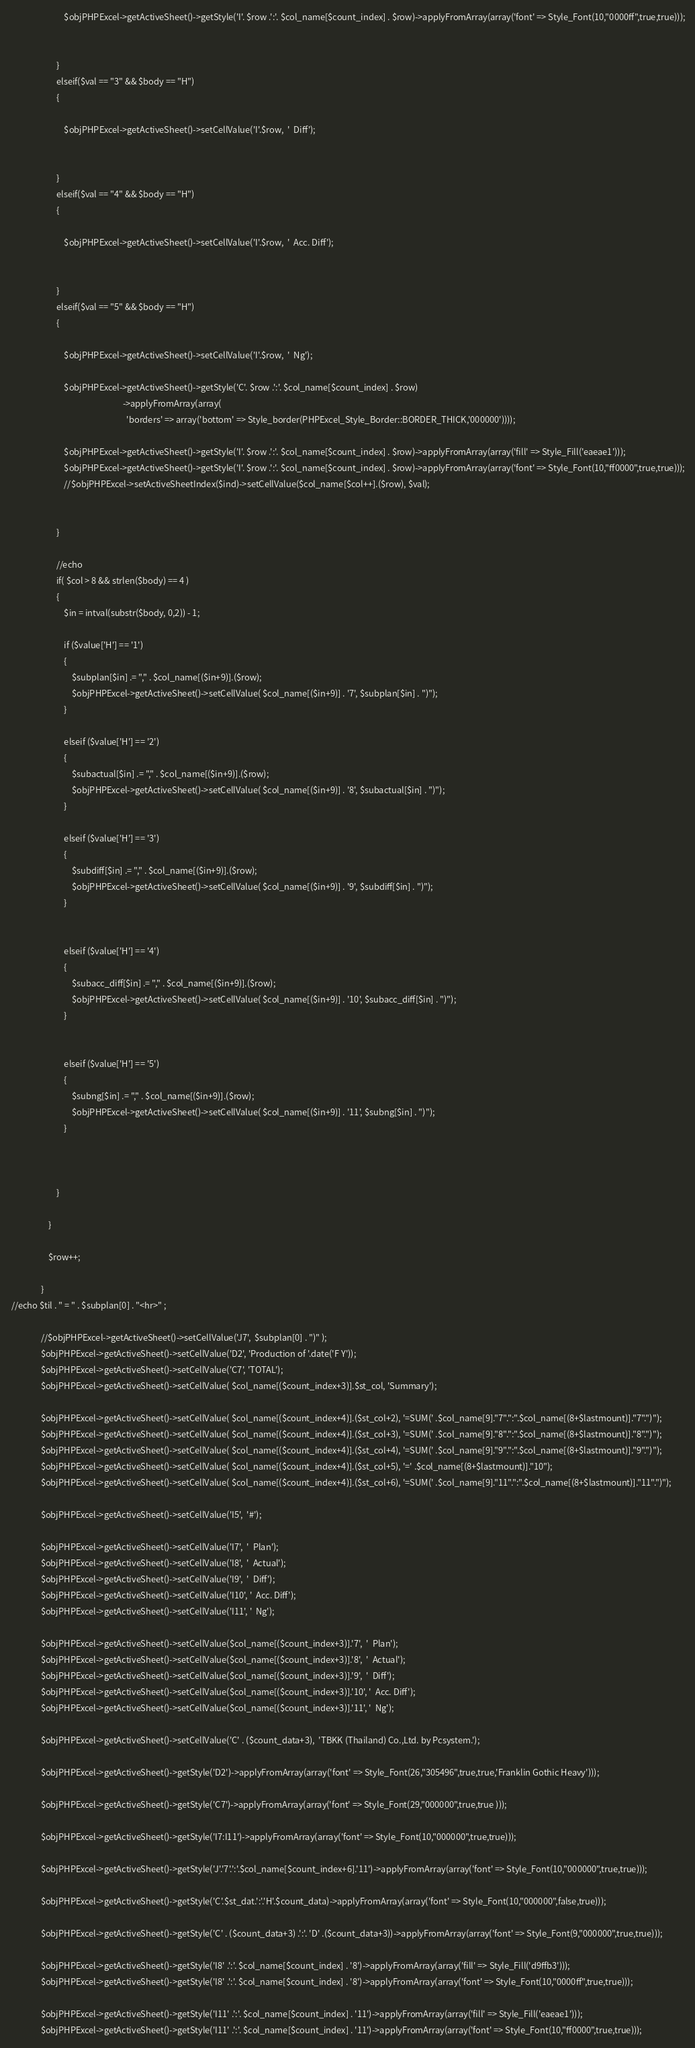<code> <loc_0><loc_0><loc_500><loc_500><_PHP_>                            $objPHPExcel->getActiveSheet()->getStyle('I'. $row .':'. $col_name[$count_index] . $row)->applyFromArray(array('font' => Style_Font(10,"0000ff",true,true)));


                        }  
                        elseif($val == "3" && $body == "H")
                        {

                            $objPHPExcel->getActiveSheet()->setCellValue('I'.$row,  '  Diff');


                        }
                        elseif($val == "4" && $body == "H")
                        {

                            $objPHPExcel->getActiveSheet()->setCellValue('I'.$row,  '  Acc. Diff');


                        }
                        elseif($val == "5" && $body == "H")
                        {

                            $objPHPExcel->getActiveSheet()->setCellValue('I'.$row,  '  Ng');

                            $objPHPExcel->getActiveSheet()->getStyle('C'. $row .':'. $col_name[$count_index] . $row)
                                                          ->applyFromArray(array(
                                                            'borders' => array('bottom' => Style_border(PHPExcel_Style_Border::BORDER_THICK,'000000'))));

                            $objPHPExcel->getActiveSheet()->getStyle('I'. $row .':'. $col_name[$count_index] . $row)->applyFromArray(array('fill' => Style_Fill('eaeae1')));
                            $objPHPExcel->getActiveSheet()->getStyle('I'. $row .':'. $col_name[$count_index] . $row)->applyFromArray(array('font' => Style_Font(10,"ff0000",true,true)));
                            //$objPHPExcel->setActiveSheetIndex($ind)->setCellValue($col_name[$col++].($row), $val);

                            
                        }  

                        //echo 
                        if( $col > 8 && strlen($body) == 4 )
                        {
                            $in = intval(substr($body, 0,2)) - 1;

                            if ($value['H'] == '1')
                            {
                                $subplan[$in] .= "," . $col_name[($in+9)].($row);
                                $objPHPExcel->getActiveSheet()->setCellValue( $col_name[($in+9)] . '7', $subplan[$in] . ")");
                            }

                            elseif ($value['H'] == '2')
                            {
                                $subactual[$in] .= "," . $col_name[($in+9)].($row);
                                $objPHPExcel->getActiveSheet()->setCellValue( $col_name[($in+9)] . '8', $subactual[$in] . ")");
                            }

                            elseif ($value['H'] == '3')
                            {
                                $subdiff[$in] .= "," . $col_name[($in+9)].($row);
                                $objPHPExcel->getActiveSheet()->setCellValue( $col_name[($in+9)] . '9', $subdiff[$in] . ")");
                            }


                            elseif ($value['H'] == '4')
                            {
                                $subacc_diff[$in] .= "," . $col_name[($in+9)].($row);
                                $objPHPExcel->getActiveSheet()->setCellValue( $col_name[($in+9)] . '10', $subacc_diff[$in] . ")");
                            }


                            elseif ($value['H'] == '5')
                            {
                                $subng[$in] .= "," . $col_name[($in+9)].($row);
                                $objPHPExcel->getActiveSheet()->setCellValue( $col_name[($in+9)] . '11', $subng[$in] . ")");
                            }                                                                                    



                        }

                    }

                    $row++;         

                }
 //echo $til . " = " . $subplan[0] . "<hr>" ;

                //$objPHPExcel->getActiveSheet()->setCellValue('J7',  $subplan[0] . ")" );
                $objPHPExcel->getActiveSheet()->setCellValue('D2', 'Production of '.date('F Y'));
                $objPHPExcel->getActiveSheet()->setCellValue('C7', 'TOTAL');
                $objPHPExcel->getActiveSheet()->setCellValue( $col_name[($count_index+3)].$st_col, 'Summary');

                $objPHPExcel->getActiveSheet()->setCellValue( $col_name[($count_index+4)].($st_col+2), '=SUM(' .$col_name[9]."7".":".$col_name[(8+$lastmount)]."7".")");
                $objPHPExcel->getActiveSheet()->setCellValue( $col_name[($count_index+4)].($st_col+3), '=SUM(' .$col_name[9]."8".":".$col_name[(8+$lastmount)]."8".")");
                $objPHPExcel->getActiveSheet()->setCellValue( $col_name[($count_index+4)].($st_col+4), '=SUM(' .$col_name[9]."9".":".$col_name[(8+$lastmount)]."9".")");
                $objPHPExcel->getActiveSheet()->setCellValue( $col_name[($count_index+4)].($st_col+5), '=' .$col_name[(8+$lastmount)]."10");
                $objPHPExcel->getActiveSheet()->setCellValue( $col_name[($count_index+4)].($st_col+6), '=SUM(' .$col_name[9]."11".":".$col_name[(8+$lastmount)]."11".")");

                $objPHPExcel->getActiveSheet()->setCellValue('I5',  '#');

                $objPHPExcel->getActiveSheet()->setCellValue('I7',  '  Plan');
                $objPHPExcel->getActiveSheet()->setCellValue('I8',  '  Actual');
                $objPHPExcel->getActiveSheet()->setCellValue('I9',  '  Diff');
                $objPHPExcel->getActiveSheet()->setCellValue('I10', '  Acc. Diff');
                $objPHPExcel->getActiveSheet()->setCellValue('I11', '  Ng');

                $objPHPExcel->getActiveSheet()->setCellValue($col_name[($count_index+3)].'7',  '  Plan');
                $objPHPExcel->getActiveSheet()->setCellValue($col_name[($count_index+3)].'8',  '  Actual');
                $objPHPExcel->getActiveSheet()->setCellValue($col_name[($count_index+3)].'9',  '  Diff');
                $objPHPExcel->getActiveSheet()->setCellValue($col_name[($count_index+3)].'10', '  Acc. Diff');
                $objPHPExcel->getActiveSheet()->setCellValue($col_name[($count_index+3)].'11', '  Ng');

                $objPHPExcel->getActiveSheet()->setCellValue('C' . ($count_data+3),  'TBKK (Thailand) Co.,Ltd. by Pcsystem.');

                $objPHPExcel->getActiveSheet()->getStyle('D2')->applyFromArray(array('font' => Style_Font(26,"305496",true,true,'Franklin Gothic Heavy')));

                $objPHPExcel->getActiveSheet()->getStyle('C7')->applyFromArray(array('font' => Style_Font(29,"000000",true,true )));

                $objPHPExcel->getActiveSheet()->getStyle('I7:I11')->applyFromArray(array('font' => Style_Font(10,"000000",true,true)));

                $objPHPExcel->getActiveSheet()->getStyle('J'.'7'.':'.$col_name[$count_index+6].'11')->applyFromArray(array('font' => Style_Font(10,"000000",true,true)));              

                $objPHPExcel->getActiveSheet()->getStyle('C'.$st_dat.':'.'H'.$count_data)->applyFromArray(array('font' => Style_Font(10,"000000",false,true)));

                $objPHPExcel->getActiveSheet()->getStyle('C' . ($count_data+3) .':'. 'D' .($count_data+3))->applyFromArray(array('font' => Style_Font(9,"000000",true,true)));

                $objPHPExcel->getActiveSheet()->getStyle('I8' .':'. $col_name[$count_index] . '8')->applyFromArray(array('fill' => Style_Fill('d9ffb3')));
                $objPHPExcel->getActiveSheet()->getStyle('I8' .':'. $col_name[$count_index] . '8')->applyFromArray(array('font' => Style_Font(10,"0000ff",true,true)));

                $objPHPExcel->getActiveSheet()->getStyle('I11' .':'. $col_name[$count_index] . '11')->applyFromArray(array('fill' => Style_Fill('eaeae1')));
                $objPHPExcel->getActiveSheet()->getStyle('I11' .':'. $col_name[$count_index] . '11')->applyFromArray(array('font' => Style_Font(10,"ff0000",true,true)));

</code> 